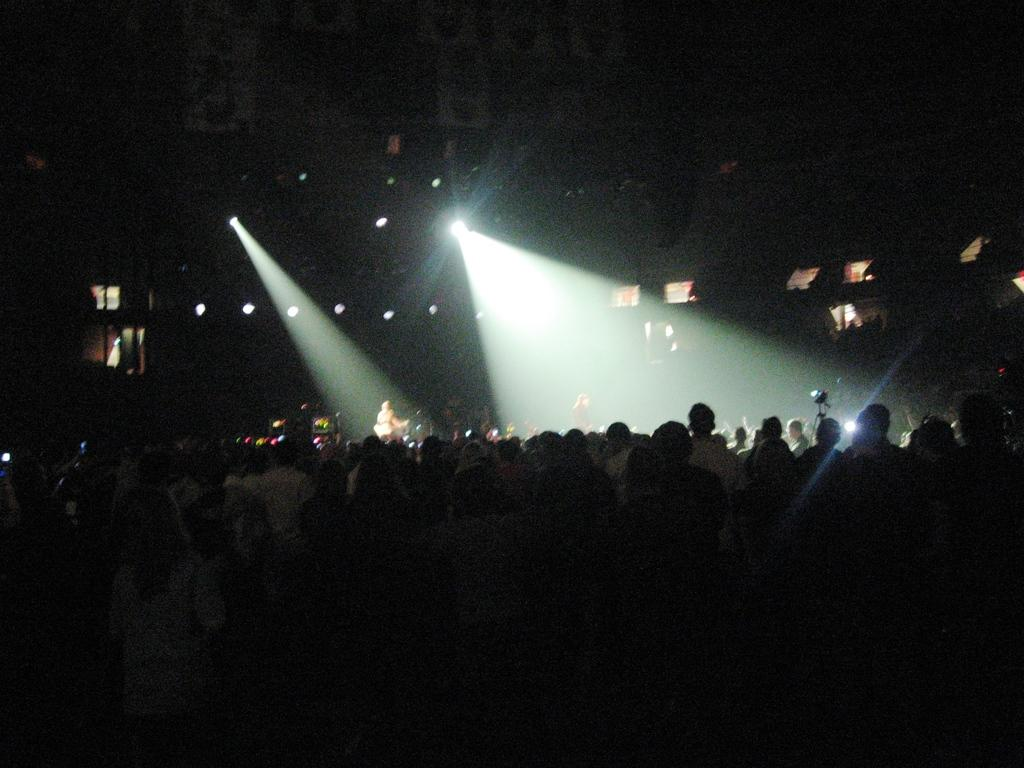How many people are in the image? There are many people in the image. What is the color of the background in the image? The background of the image is dark. What can be seen in the background of the image? There are lights visible in the background, as well as an object on a stand and other objects. Can you tell me how many rivers are flowing through the room in the image? There is no river present in the image; it is an indoor setting with a dark background and various objects visible. 